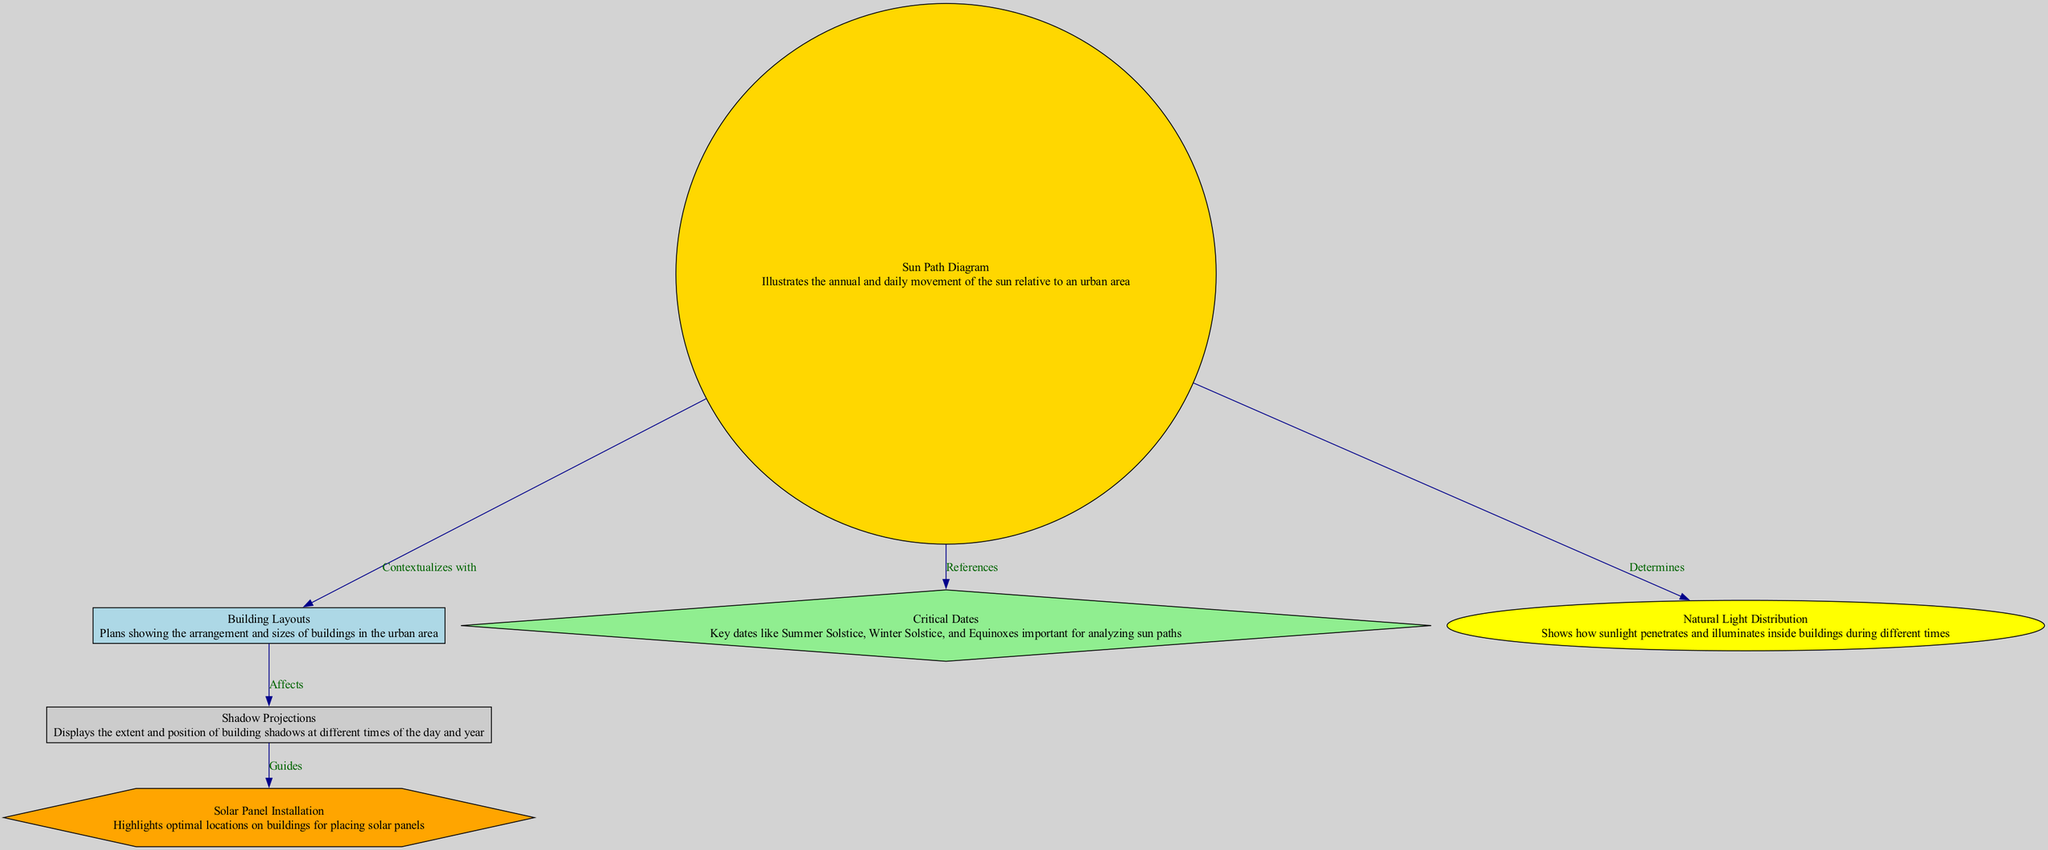What is the main subject of the diagram? The diagram focuses on the "Sun Path Diagram," which represents the sun's movement throughout the year in relation to an urban setting.
Answer: Sun Path Diagram Which element is shown to contextualize with the Sun Path Diagram? According to the edges in the diagram, the "Building Layouts" node connects to the "Sun Path Diagram" node, indicating it provides context for understanding the sun's path.
Answer: Building Layouts How many nodes are present in this diagram? By counting all the unique nodes listed in the provided data, there are six nodes: Sun Path Diagram, Building Layouts, Shadow Projections, Critical Dates, Solar Panel Installation, and Natural Light Distribution.
Answer: 6 What relationship guides the Shadow Projections? The Shadow Projections node is guided by the relationship with Solar Panel Installation, as indicated by the edge labeled "Guides" connecting these two nodes.
Answer: Guides What does the diagram determine about Natural Light Distribution? The edge labeled "Determines" indicates that the Sun Path Diagram directly affects the Natural Light Distribution within buildings.
Answer: Determines What are the key critical dates mentioned in the diagram context? The "Critical Dates" node references important dates like Summer Solstice, Winter Solstice, and Equinoxes, which are essential for analyzing sun paths.
Answer: Summer Solstice, Winter Solstice, Equinoxes Which type of installations does the diagram highlight regarding building design? The diagram highlights locations for "Solar Panel Installation," which are optimal spots on buildings where solar panels can be placed effectively.
Answer: Solar Panel Installation What shape represents the Building Layouts in the diagram? The shape used for representing Building Layouts is a rectangle, as specified by the node style attributes in the rendered diagram.
Answer: Rectangle How does the Sun Path Diagram affect sunlight penetration in buildings? Sun Path Diagram influences how sunlight penetrates inside buildings by determining the natural light distribution at different times, as shown in the corresponding edge.
Answer: Determines 